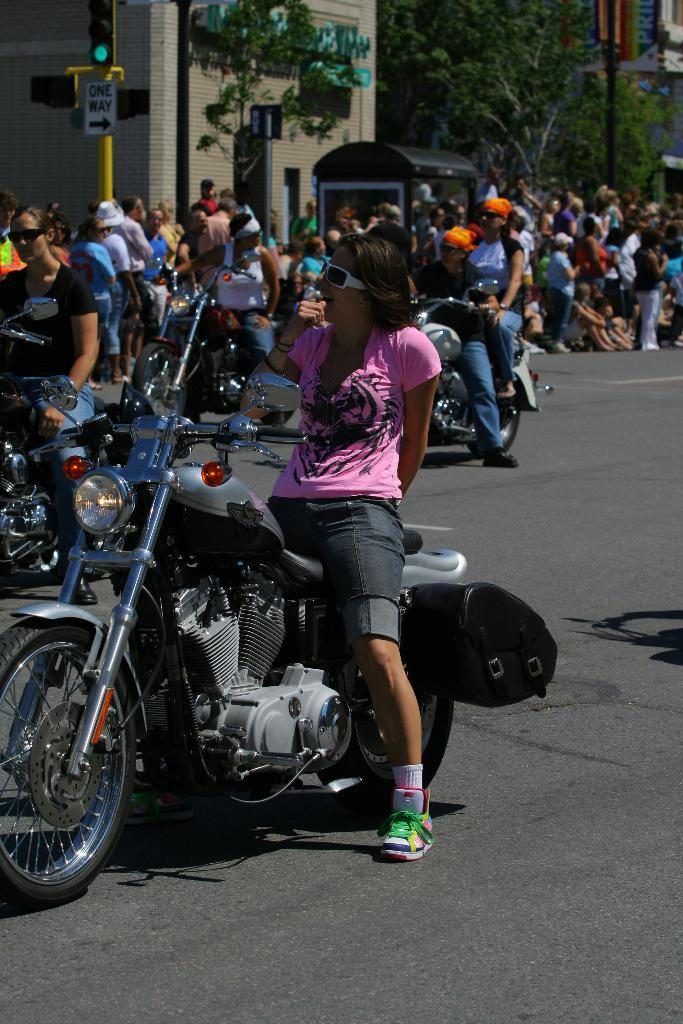Where was the image taken? The image was taken on a road. What is the woman in the image doing? The woman is sitting on a bike. Can you describe the background of the image? There are many people in the background. Are there any other people riding bikes in the image? Yes, there are at least two more guys riding a bike in the background. What type of shake is being served during the recess in the image? There is no mention of a shake or recess in the image; it features a woman sitting on a bike and people in the background. 